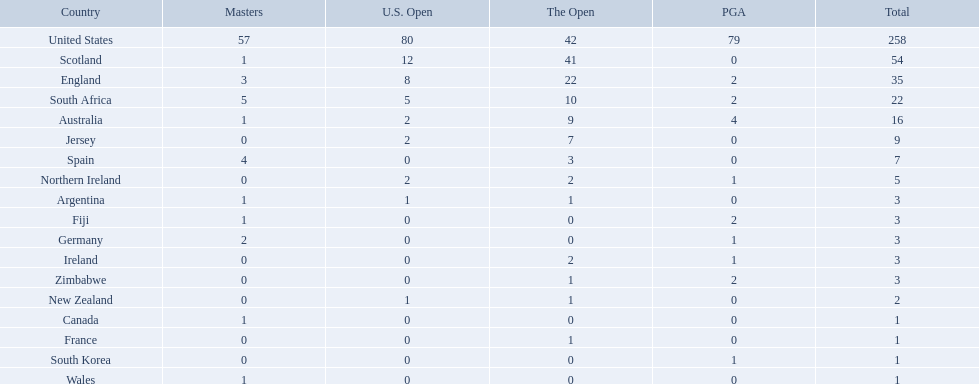What are all the countries? United States, Scotland, England, South Africa, Australia, Jersey, Spain, Northern Ireland, Argentina, Fiji, Germany, Ireland, Zimbabwe, New Zealand, Canada, France, South Korea, Wales. Which ones are located in africa? South Africa, Zimbabwe. Of those, which has the least champion golfers? Zimbabwe. Which of the mentioned nations are african? South Africa, Zimbabwe. Which of them has the fewest championship-winning golf players? Zimbabwe. What are all the nations? United States, Scotland, England, South Africa, Australia, Jersey, Spain, Northern Ireland, Argentina, Fiji, Germany, Ireland, Zimbabwe, New Zealand, Canada, France, South Korea, Wales. Which ones are found in africa? South Africa, Zimbabwe. Of those, which has the least number of champion golfers? Zimbabwe. Would you be able to parse every entry in this table? {'header': ['Country', 'Masters', 'U.S. Open', 'The Open', 'PGA', 'Total'], 'rows': [['United States', '57', '80', '42', '79', '258'], ['Scotland', '1', '12', '41', '0', '54'], ['England', '3', '8', '22', '2', '35'], ['South Africa', '5', '5', '10', '2', '22'], ['Australia', '1', '2', '9', '4', '16'], ['Jersey', '0', '2', '7', '0', '9'], ['Spain', '4', '0', '3', '0', '7'], ['Northern Ireland', '0', '2', '2', '1', '5'], ['Argentina', '1', '1', '1', '0', '3'], ['Fiji', '1', '0', '0', '2', '3'], ['Germany', '2', '0', '0', '1', '3'], ['Ireland', '0', '0', '2', '1', '3'], ['Zimbabwe', '0', '0', '1', '2', '3'], ['New Zealand', '0', '1', '1', '0', '2'], ['Canada', '1', '0', '0', '0', '1'], ['France', '0', '0', '1', '0', '1'], ['South Korea', '0', '0', '0', '1', '1'], ['Wales', '1', '0', '0', '0', '1']]} What are all the nations? United States, Scotland, England, South Africa, Australia, Jersey, Spain, Northern Ireland, Argentina, Fiji, Germany, Ireland, Zimbabwe, New Zealand, Canada, France, South Korea, Wales. Which ones are situated in africa? South Africa, Zimbabwe. Of those, which has the fewest champion golfers? Zimbabwe. Which of the enumerated countries belong to africa? South Africa, Zimbabwe. Which among them has the smallest number of champion golfers? Zimbabwe. What is the complete list of nations? United States, Scotland, England, South Africa, Australia, Jersey, Spain, Northern Ireland, Argentina, Fiji, Germany, Ireland, Zimbabwe, New Zealand, Canada, France, South Korea, Wales. Which of these nations can be found in africa? South Africa, Zimbabwe. Among them, which one has the fewest renowned golfers? Zimbabwe. 